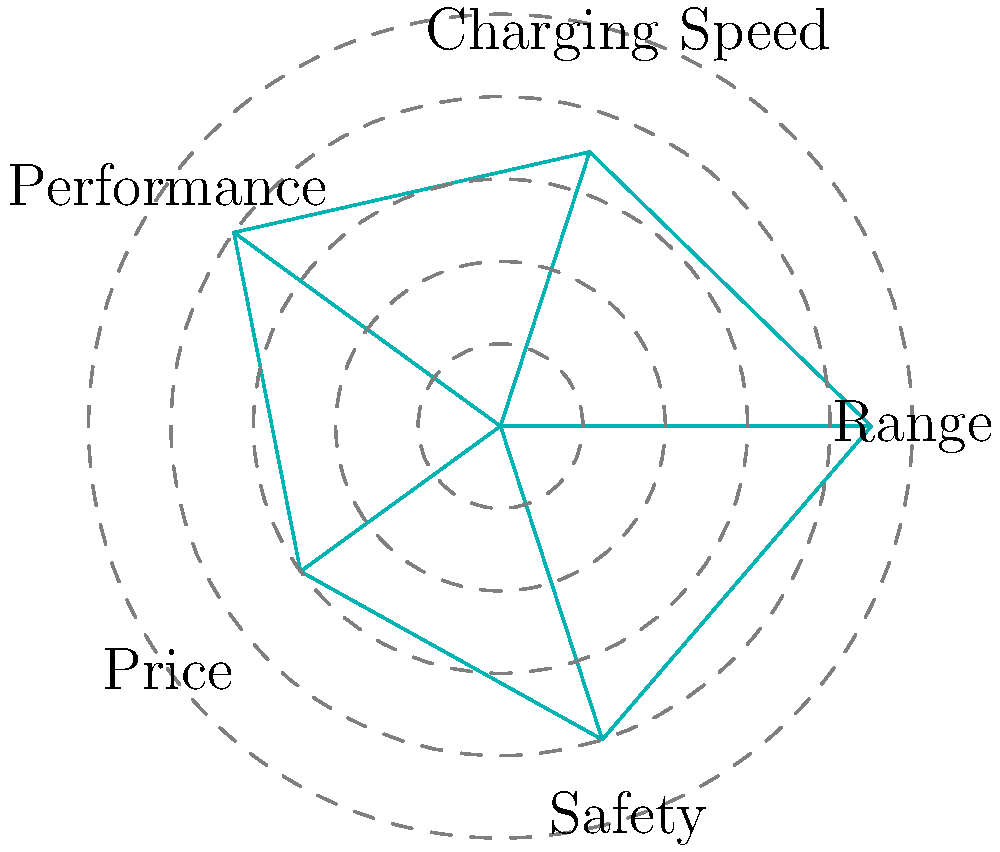Based on the radar chart comparing EV features, which area appears to be the weakest for the analyzed electric vehicle model, potentially requiring improvement to enhance competitiveness? To determine the weakest area for the analyzed electric vehicle model, we need to examine each feature represented in the radar chart:

1. Range: Extends to about 9 units on the chart, indicating strong performance.
2. Charging Speed: Reaches approximately 7 units, showing good performance.
3. Performance: Extends to about 8 units, demonstrating strong capabilities.
4. Price: Only reaches about 6 units, the lowest point on the chart.
5. Safety: Extends to about 8 units, indicating good safety features.

By comparing these values, we can see that Price has the lowest score at approximately 6 units. This suggests that the price point of the vehicle might be less competitive compared to its other features.

In the context of an electric vehicle manufacturer seeking investment and strategic guidance to scale operations, addressing the price factor could be crucial. Improving competitiveness in this area might involve:

1. Optimizing production costs to lower the final price.
2. Developing strategies to increase perceived value for the given price.
3. Exploring ways to offer more competitive financing or leasing options.

Therefore, the area that appears to be the weakest and potentially requiring improvement to enhance competitiveness is Price.
Answer: Price 